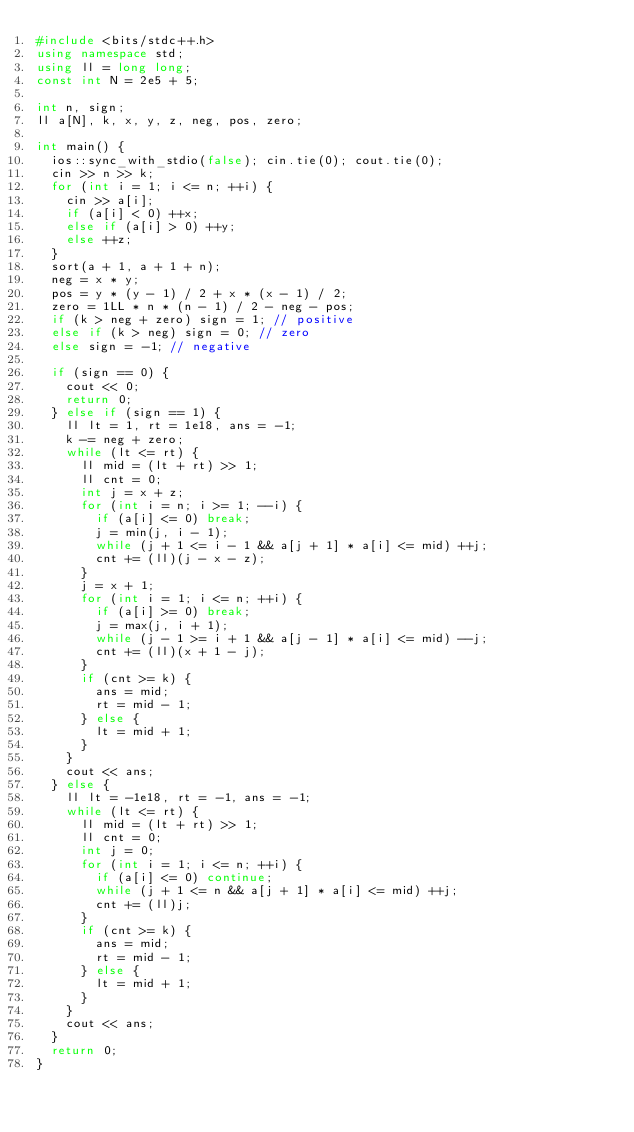Convert code to text. <code><loc_0><loc_0><loc_500><loc_500><_C++_>#include <bits/stdc++.h>
using namespace std;
using ll = long long;
const int N = 2e5 + 5;

int n, sign;
ll a[N], k, x, y, z, neg, pos, zero;

int main() {
  ios::sync_with_stdio(false); cin.tie(0); cout.tie(0);
  cin >> n >> k;
  for (int i = 1; i <= n; ++i) {
    cin >> a[i];
    if (a[i] < 0) ++x;
    else if (a[i] > 0) ++y;
    else ++z;
  }
  sort(a + 1, a + 1 + n);
  neg = x * y;
  pos = y * (y - 1) / 2 + x * (x - 1) / 2;
  zero = 1LL * n * (n - 1) / 2 - neg - pos;
  if (k > neg + zero) sign = 1; // positive
  else if (k > neg) sign = 0; // zero
  else sign = -1; // negative

  if (sign == 0) {
    cout << 0;
    return 0;
  } else if (sign == 1) {
    ll lt = 1, rt = 1e18, ans = -1;
    k -= neg + zero;
    while (lt <= rt) {
      ll mid = (lt + rt) >> 1;
      ll cnt = 0;
      int j = x + z;
      for (int i = n; i >= 1; --i) {
        if (a[i] <= 0) break;
        j = min(j, i - 1);
        while (j + 1 <= i - 1 && a[j + 1] * a[i] <= mid) ++j;
        cnt += (ll)(j - x - z);
      }
      j = x + 1;
      for (int i = 1; i <= n; ++i) {
        if (a[i] >= 0) break;
        j = max(j, i + 1);
        while (j - 1 >= i + 1 && a[j - 1] * a[i] <= mid) --j;
        cnt += (ll)(x + 1 - j);
      }
      if (cnt >= k) {
        ans = mid;
        rt = mid - 1;
      } else {
        lt = mid + 1;
      }
    }
    cout << ans;
  } else {
    ll lt = -1e18, rt = -1, ans = -1;
    while (lt <= rt) {
      ll mid = (lt + rt) >> 1;
      ll cnt = 0;
      int j = 0;
      for (int i = 1; i <= n; ++i) {
        if (a[i] <= 0) continue;
        while (j + 1 <= n && a[j + 1] * a[i] <= mid) ++j;
        cnt += (ll)j;
      }
      if (cnt >= k) {
        ans = mid;
        rt = mid - 1;
      } else {
        lt = mid + 1;
      }
    }
    cout << ans;
  }
  return 0;
}</code> 